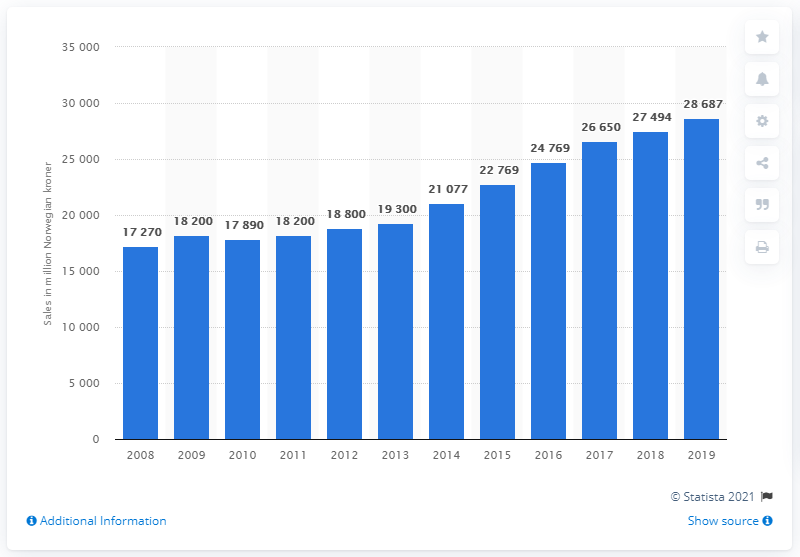Specify some key components in this picture. The turnover of prescription pharmaceuticals in Norway in 2019 was 24,769. Pharmaceutical sales in Norway increased almost annually from 2010 to 2020. 